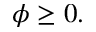Convert formula to latex. <formula><loc_0><loc_0><loc_500><loc_500>\phi \geq 0 .</formula> 